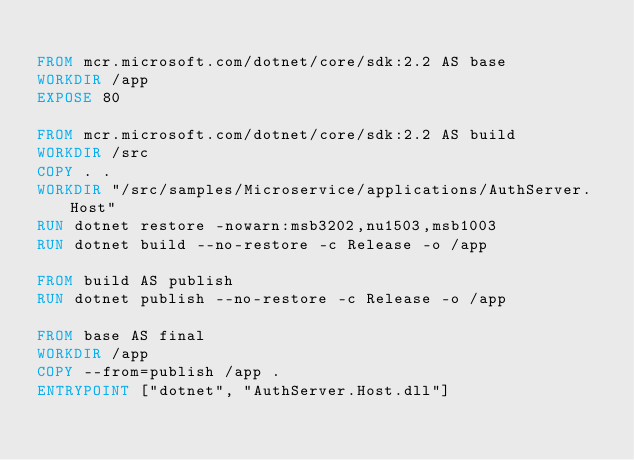Convert code to text. <code><loc_0><loc_0><loc_500><loc_500><_Dockerfile_>
FROM mcr.microsoft.com/dotnet/core/sdk:2.2 AS base
WORKDIR /app
EXPOSE 80

FROM mcr.microsoft.com/dotnet/core/sdk:2.2 AS build
WORKDIR /src
COPY . .
WORKDIR "/src/samples/Microservice/applications/AuthServer.Host"
RUN dotnet restore -nowarn:msb3202,nu1503,msb1003
RUN dotnet build --no-restore -c Release -o /app

FROM build AS publish
RUN dotnet publish --no-restore -c Release -o /app

FROM base AS final
WORKDIR /app
COPY --from=publish /app .
ENTRYPOINT ["dotnet", "AuthServer.Host.dll"]</code> 